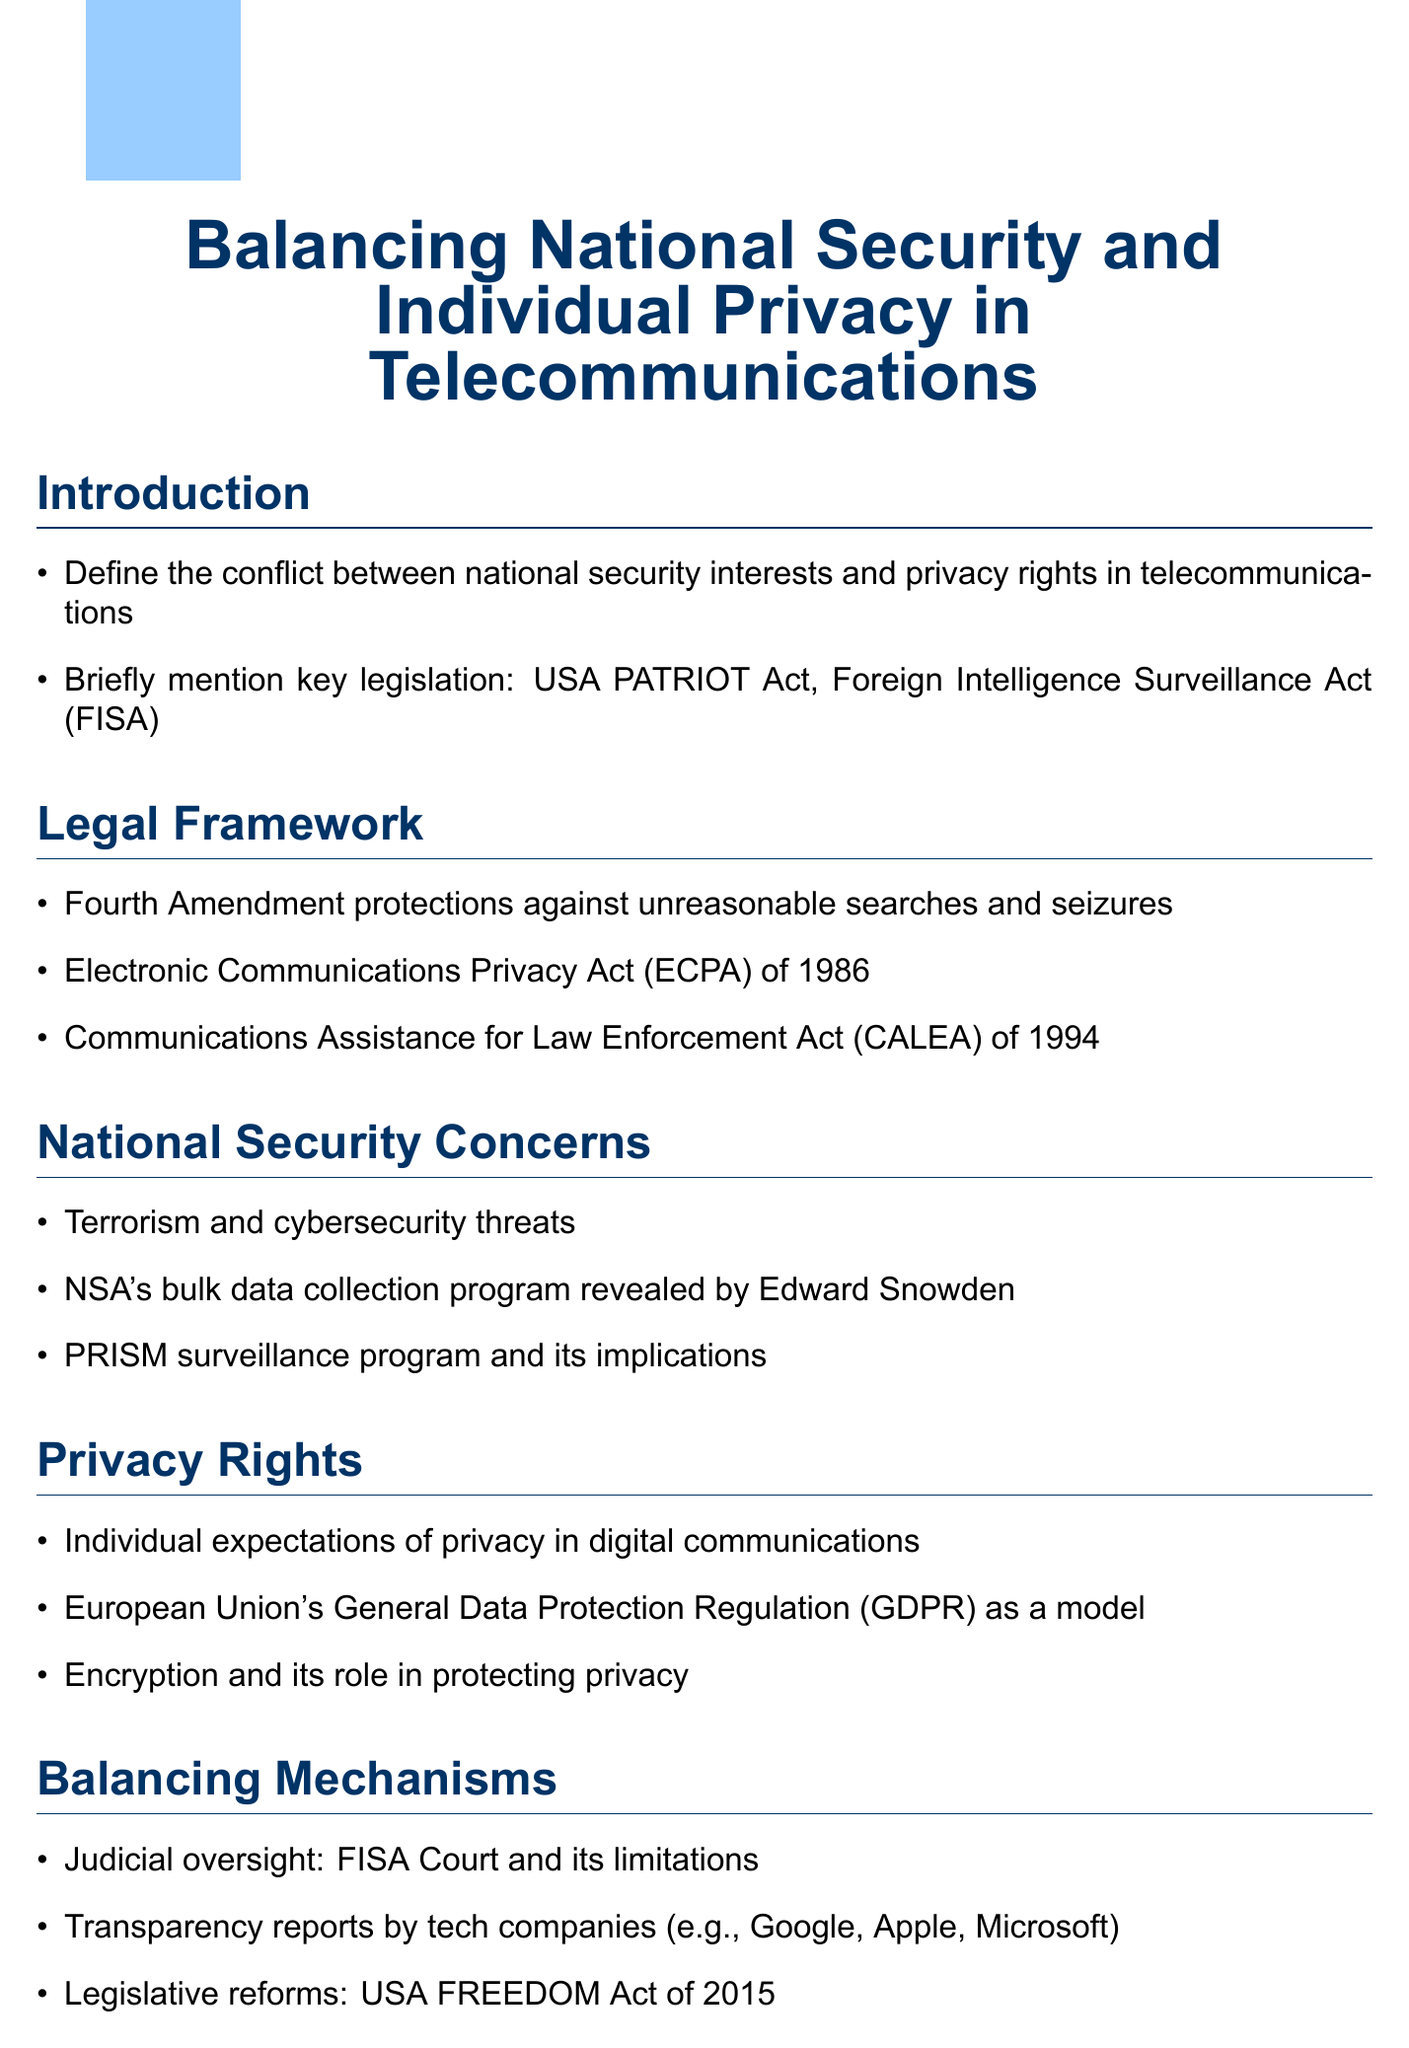What is the main conflict discussed in the document? The document focuses on the tension between national security interests and privacy rights in telecommunications.
Answer: national security interests and privacy rights Which key legislation is mentioned in the introduction? The introduction briefly mentions two key pieces of legislation related to the topic.
Answer: USA PATRIOT Act, Foreign Intelligence Surveillance Act What protections does the Fourth Amendment provide? The document refers to the Fourth Amendment protections against a specific type of governmental action.
Answer: unreasonable searches and seizures What act was enacted in 1986? The Legal Framework section includes a specific act that was established in 1986.
Answer: Electronic Communications Privacy Act What major surveillance program was revealed by Edward Snowden? In the National Security Concerns section, a significant program is discussed that was brought to public attention by Edward Snowden.
Answer: NSA's bulk data collection program Which European regulation is referenced as a model for privacy? The Privacy Rights section mentions a specific regulation from the European Union considered as a privacy model.
Answer: General Data Protection Regulation What is one of the case studies included in the document? The Case Studies section lists important legal cases relevant to privacy and security issues.
Answer: Apple vs. FBI (2016) What organization is responsible for judicial oversight mentioned in the balancing mechanisms? The Balancing Mechanisms section identifies a specific court that plays a role in judicial oversight related to national security and privacy.
Answer: FISA Court What is emphasized in the conclusion regarding public engagement? The conclusion discusses the importance of a certain aspect related to public participation in the dialogue about privacy and security.
Answer: public awareness and debate 